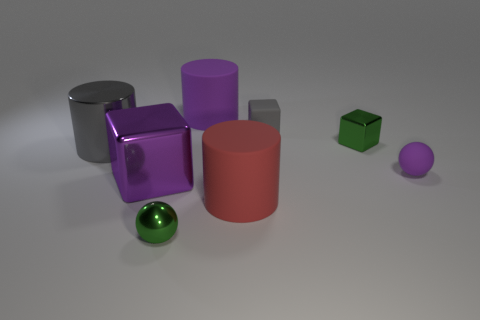Add 2 big red matte objects. How many objects exist? 10 Subtract all blocks. How many objects are left? 5 Add 5 tiny metal things. How many tiny metal things exist? 7 Subtract 0 brown cylinders. How many objects are left? 8 Subtract all tiny purple matte balls. Subtract all small metal objects. How many objects are left? 5 Add 8 small metal blocks. How many small metal blocks are left? 9 